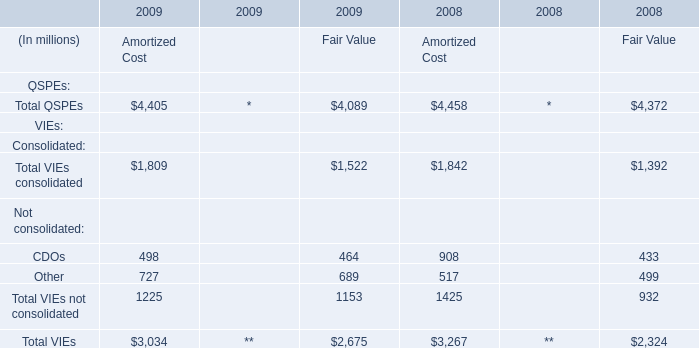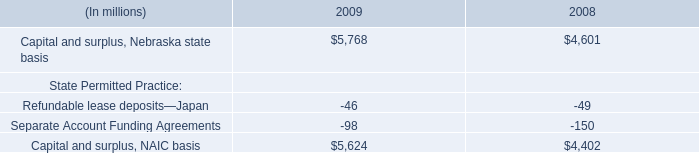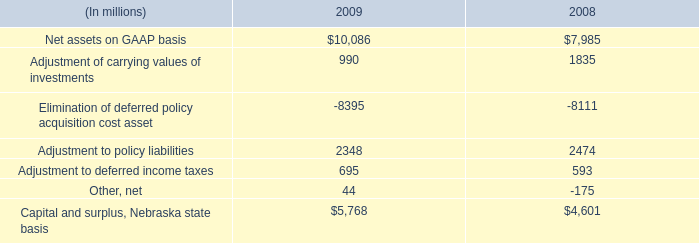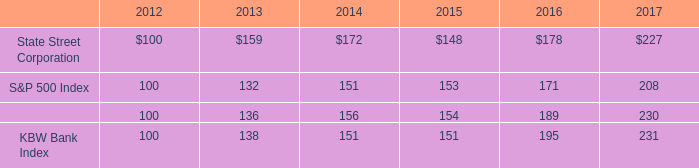What is the average amount of Adjustment of carrying values of investments of 2008, and Capital and surplus, Nebraska state basis of 2009 ? 
Computations: ((1835.0 + 5768.0) / 2)
Answer: 3801.5. 